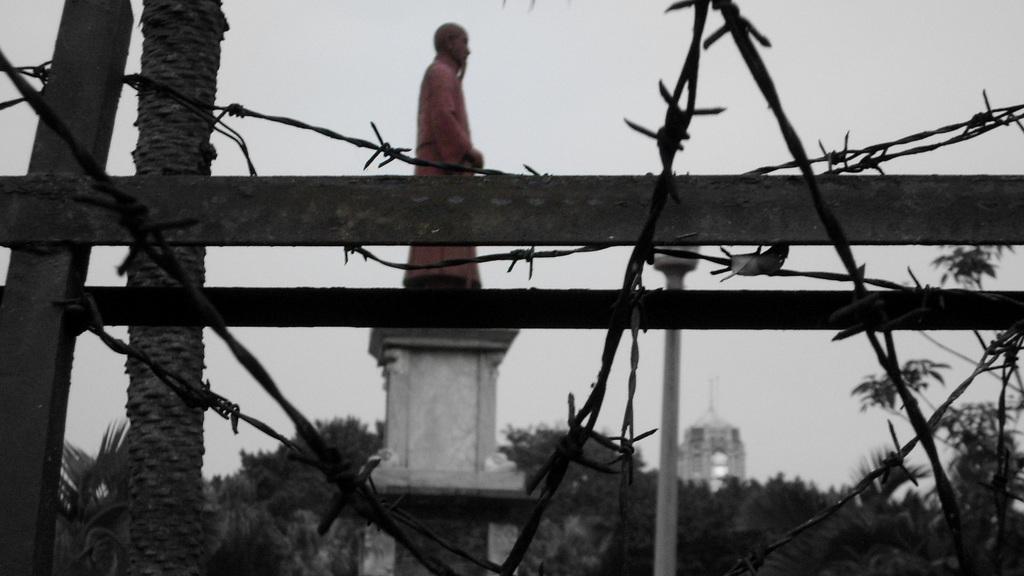Can you describe this image briefly? In this image in the front there are wires. In the center there is a wooden fence, there is a tree trunk and there is a statue on the pillar and there are trees in the background and there is a tower. 